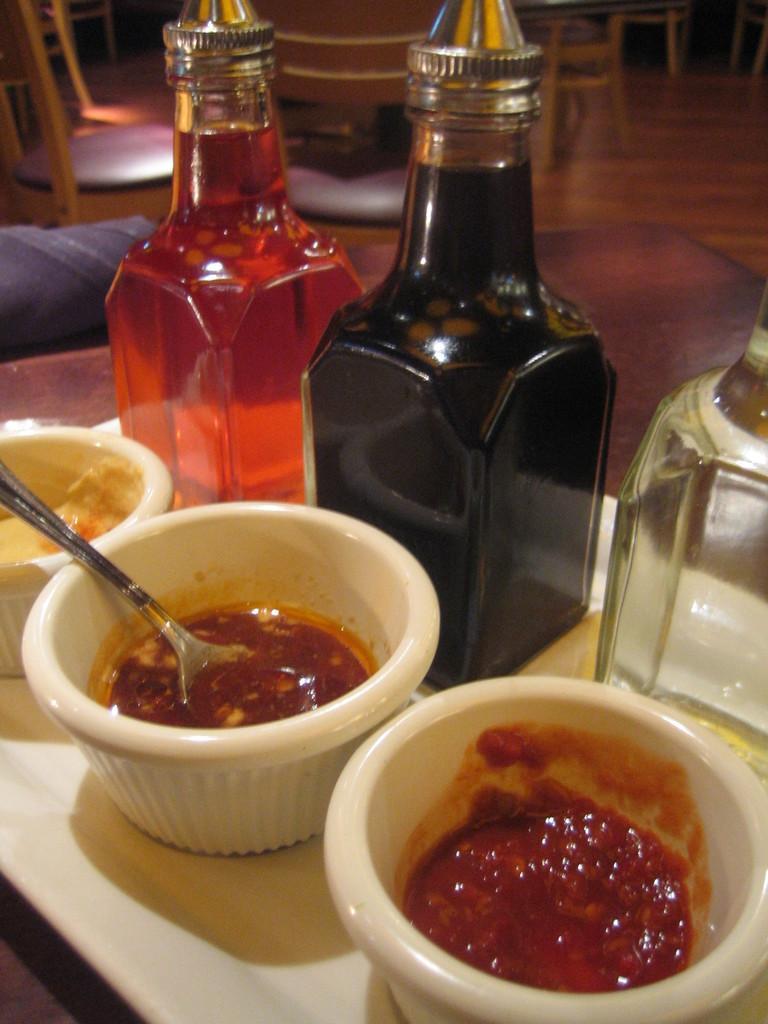Describe this image in one or two sentences. in this image i can see bowls and food in that. behind that there are three bottles. behind the bottles there are chairs and tables. 